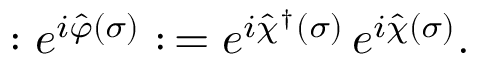Convert formula to latex. <formula><loc_0><loc_0><loc_500><loc_500>\colon e ^ { i \hat { \varphi } ( \sigma ) } \colon \, = e ^ { i \hat { \chi } ^ { \dagger } ( \sigma ) } \, e ^ { i \hat { \chi } ( \sigma ) } .</formula> 